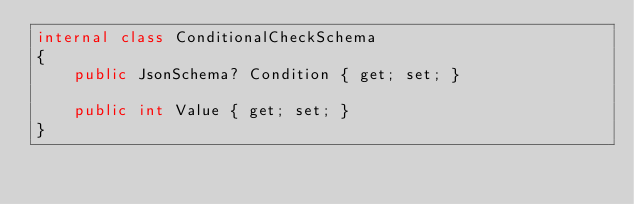Convert code to text. <code><loc_0><loc_0><loc_500><loc_500><_C#_>internal class ConditionalCheckSchema
{
    public JsonSchema? Condition { get; set; }

    public int Value { get; set; }
}
</code> 